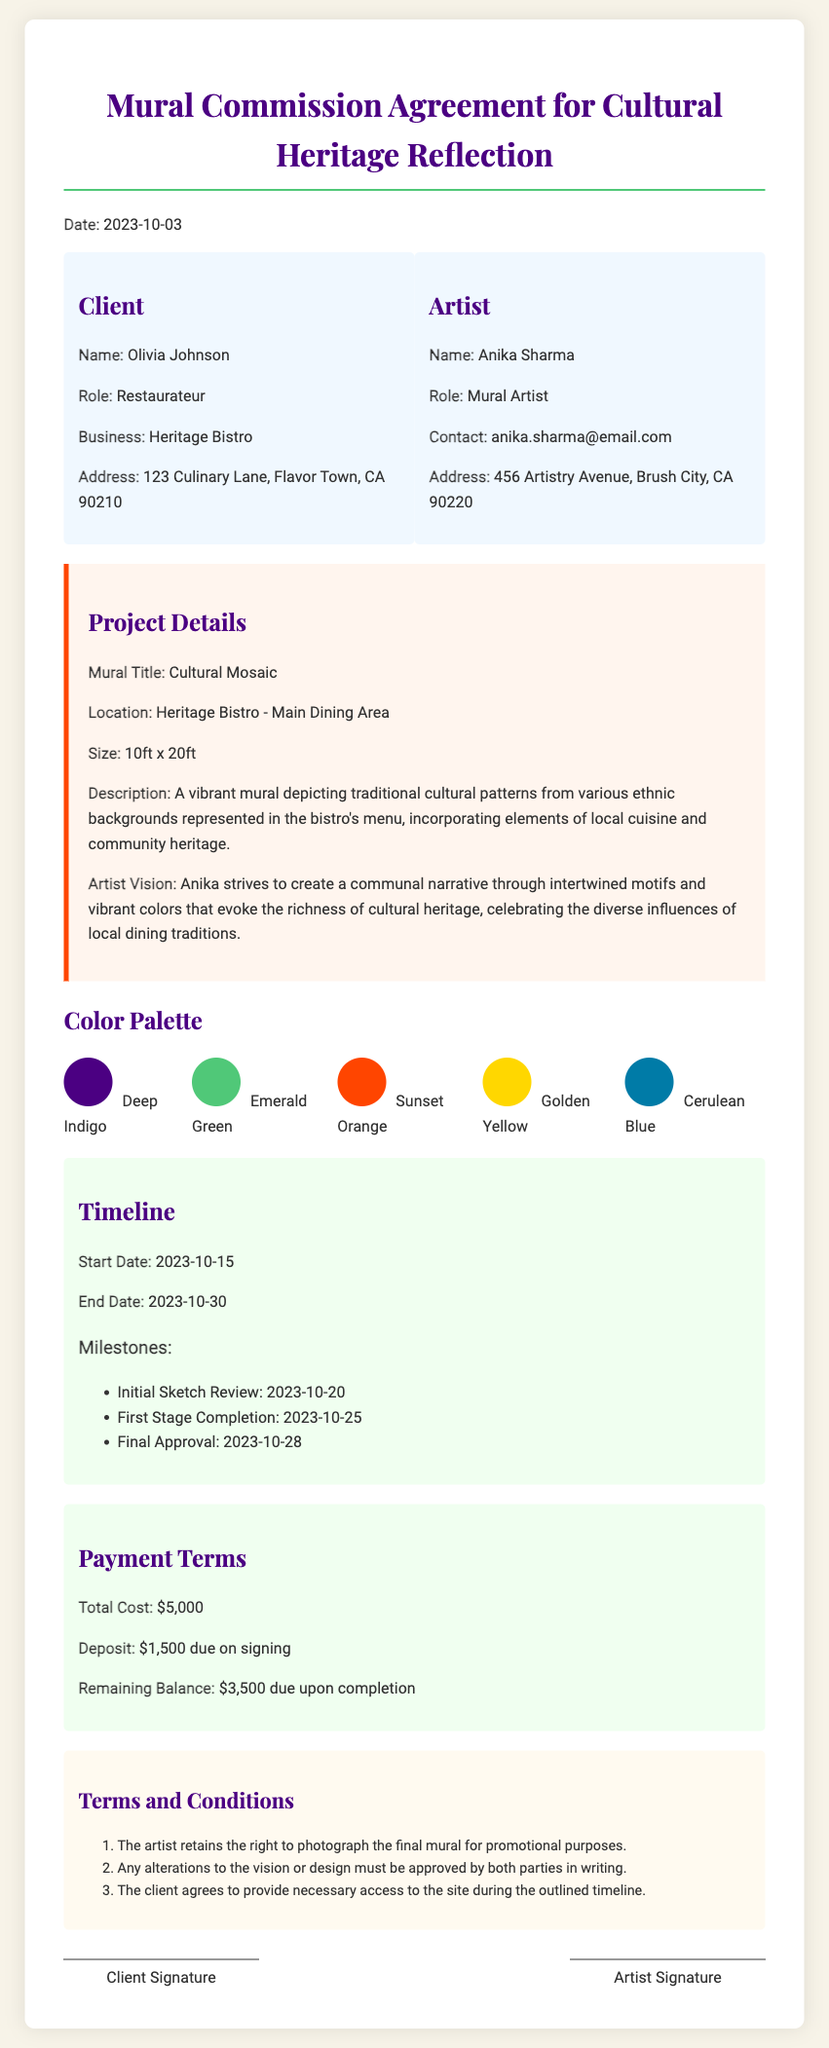what is the title of the mural? The title of the mural is stated in the project details.
Answer: Cultural Mosaic who is the artist? The artist's name is listed in the document under the artist section.
Answer: Anika Sharma what is the total cost of the mural? The total cost is outlined in the payment terms of the document.
Answer: $5,000 what is the size of the mural? The size is specified in the project details section of the document.
Answer: 10ft x 20ft when is the final approval date? The final approval date is mentioned in the timeline section as a milestone.
Answer: 2023-10-28 how much is the deposit due on signing? The deposit amount can be found in the payment terms section of the document.
Answer: $1,500 what is the main theme of the mural? The theme is described in the project details, focusing on cultural representation.
Answer: Cultural patterns from various ethnic backgrounds who retains the right to photograph the mural? This information is included in the terms and conditions of the document.
Answer: The artist 